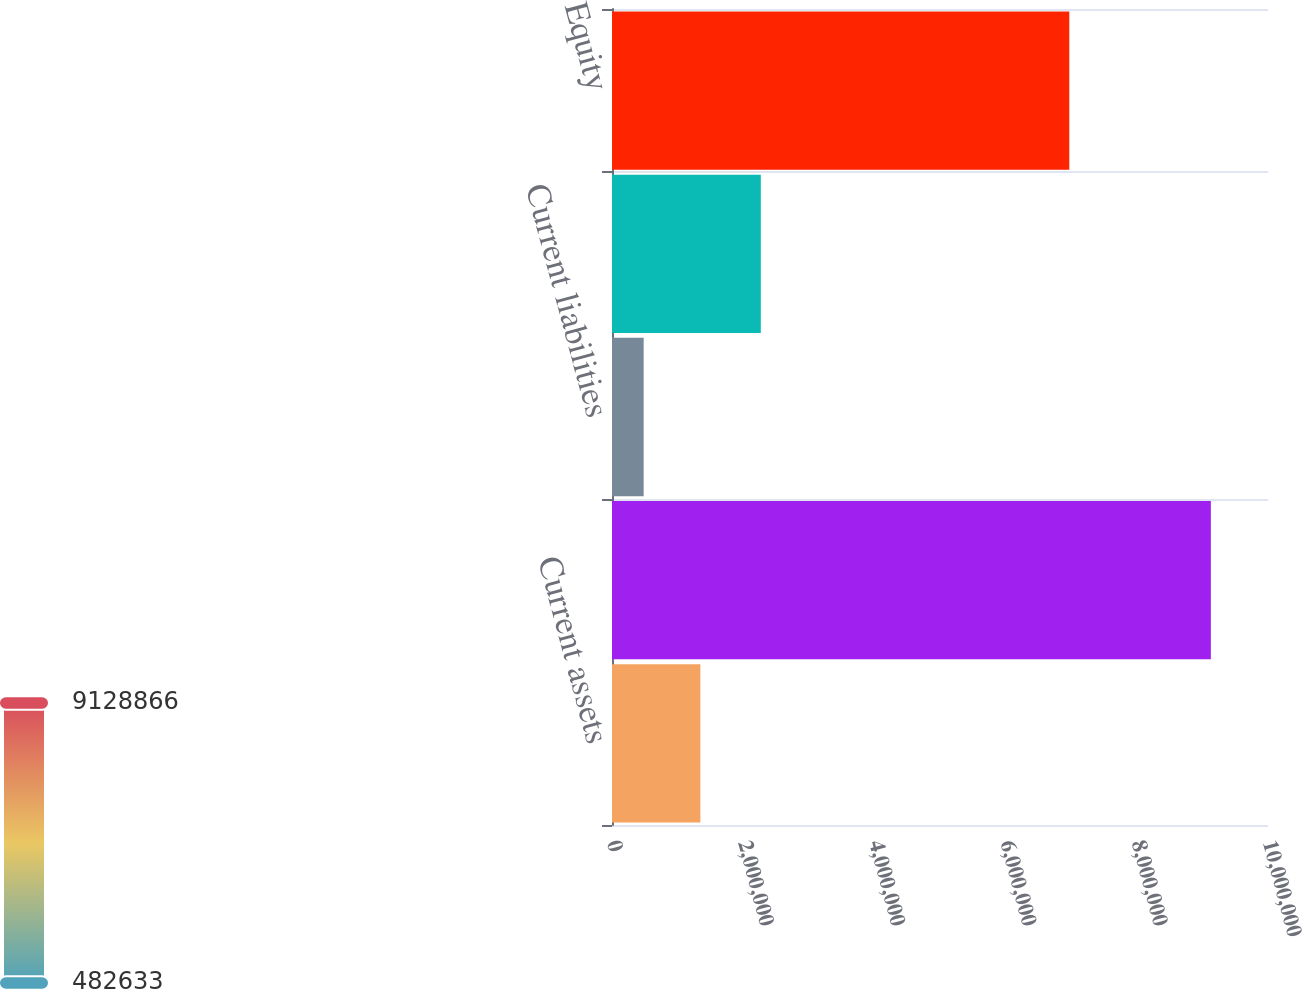Convert chart. <chart><loc_0><loc_0><loc_500><loc_500><bar_chart><fcel>Current assets<fcel>Property and other assets net<fcel>Current liabilities<fcel>Long-term debt and other<fcel>Equity<nl><fcel>1.34726e+06<fcel>9.12887e+06<fcel>482633<fcel>2.26816e+06<fcel>6.97096e+06<nl></chart> 